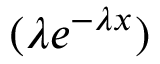Convert formula to latex. <formula><loc_0><loc_0><loc_500><loc_500>( \lambda e ^ { - \lambda x } )</formula> 